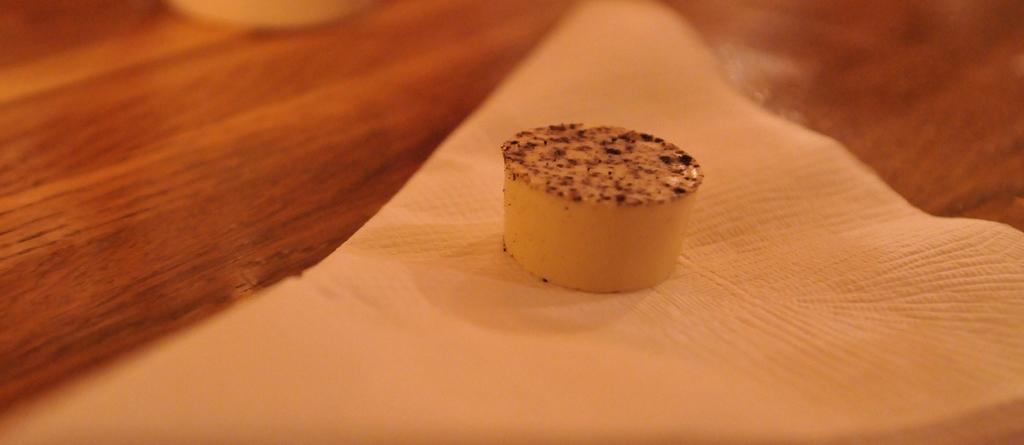Please provide a concise description of this image. This picture shows some food on the napkin on the table. 